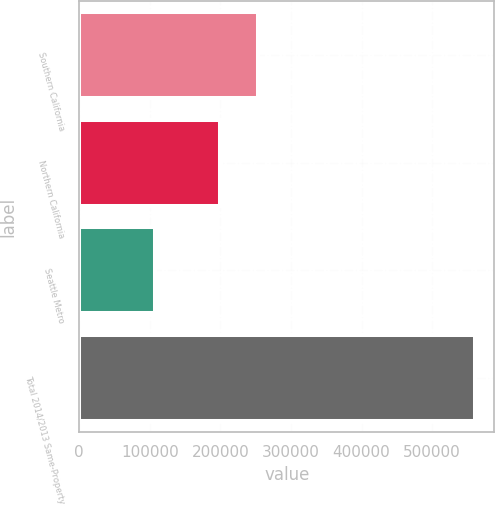Convert chart to OTSL. <chart><loc_0><loc_0><loc_500><loc_500><bar_chart><fcel>Southern California<fcel>Northern California<fcel>Seattle Metro<fcel>Total 2014/2013 Same-Property<nl><fcel>253503<fcel>199395<fcel>107225<fcel>560123<nl></chart> 